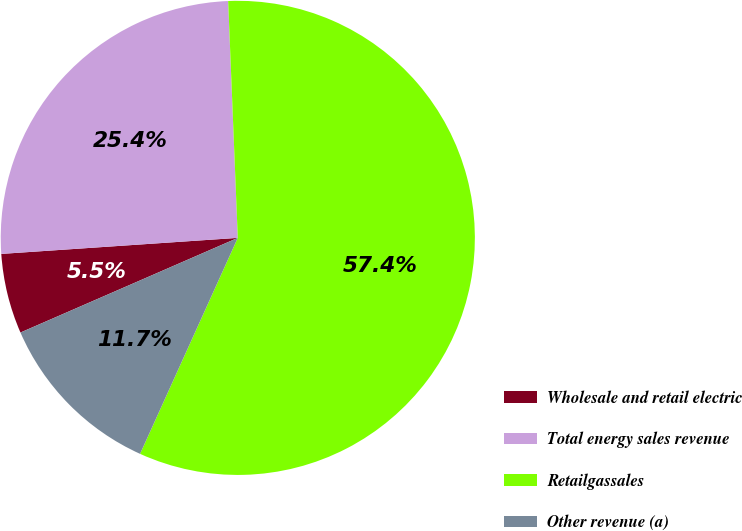Convert chart to OTSL. <chart><loc_0><loc_0><loc_500><loc_500><pie_chart><fcel>Wholesale and retail electric<fcel>Total energy sales revenue<fcel>Retailgassales<fcel>Other revenue (a)<nl><fcel>5.46%<fcel>25.43%<fcel>57.41%<fcel>11.7%<nl></chart> 